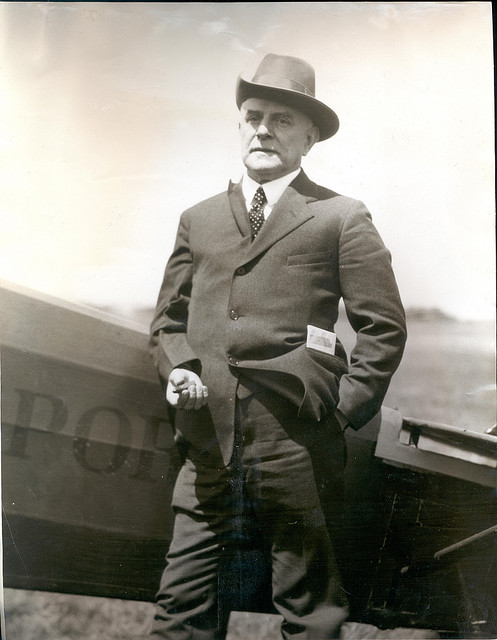Identify the text displayed in this image. POR 